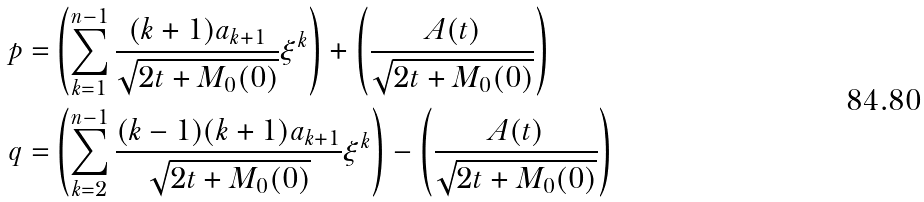<formula> <loc_0><loc_0><loc_500><loc_500>p = & \left ( \sum _ { k = 1 } ^ { n - 1 } \frac { ( k + 1 ) a _ { k + 1 } } { \sqrt { 2 t + M _ { 0 } ( 0 ) } } \xi ^ { k } \right ) + \left ( \frac { A ( t ) } { \sqrt { 2 t + M _ { 0 } ( 0 ) } } \right ) \\ q = & \left ( \sum _ { k = 2 } ^ { n - 1 } \frac { ( k - 1 ) ( k + 1 ) a _ { k + 1 } } { \sqrt { 2 t + M _ { 0 } ( 0 ) } } \xi ^ { k } \right ) - \left ( \frac { A ( t ) } { \sqrt { 2 t + M _ { 0 } ( 0 ) } } \right )</formula> 